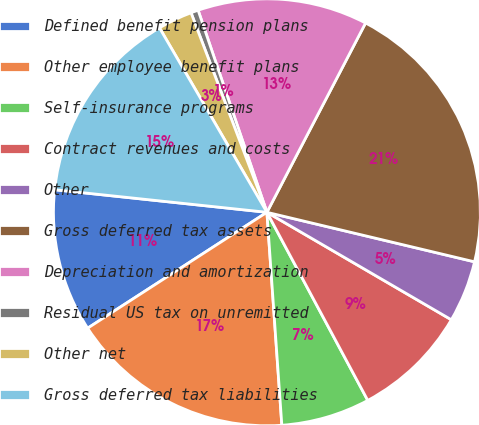Convert chart to OTSL. <chart><loc_0><loc_0><loc_500><loc_500><pie_chart><fcel>Defined benefit pension plans<fcel>Other employee benefit plans<fcel>Self-insurance programs<fcel>Contract revenues and costs<fcel>Other<fcel>Gross deferred tax assets<fcel>Depreciation and amortization<fcel>Residual US tax on unremitted<fcel>Other net<fcel>Gross deferred tax liabilities<nl><fcel>10.82%<fcel>16.98%<fcel>6.72%<fcel>8.77%<fcel>4.67%<fcel>21.08%<fcel>12.87%<fcel>0.56%<fcel>2.61%<fcel>14.92%<nl></chart> 